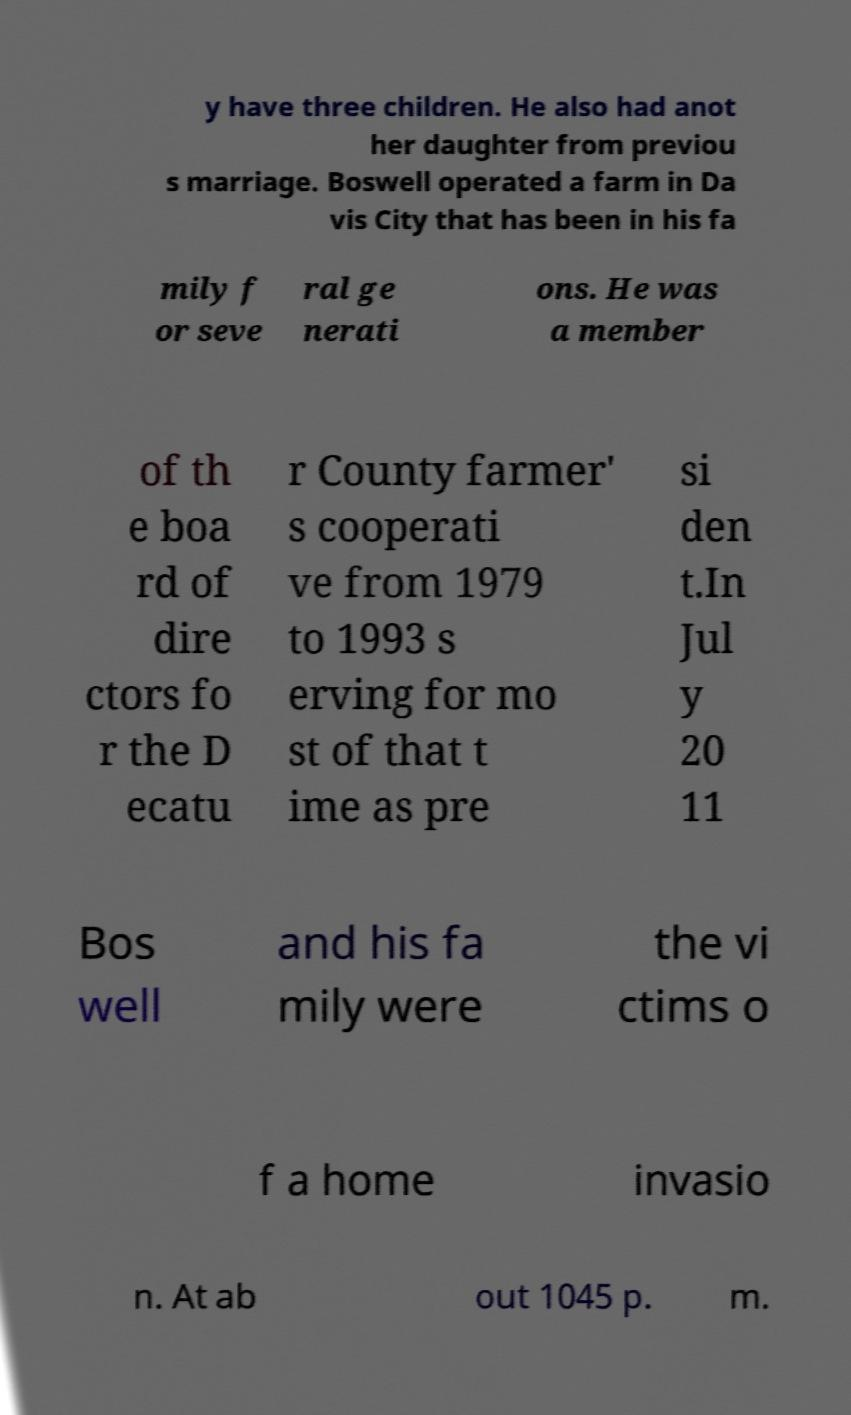Please read and relay the text visible in this image. What does it say? y have three children. He also had anot her daughter from previou s marriage. Boswell operated a farm in Da vis City that has been in his fa mily f or seve ral ge nerati ons. He was a member of th e boa rd of dire ctors fo r the D ecatu r County farmer' s cooperati ve from 1979 to 1993 s erving for mo st of that t ime as pre si den t.In Jul y 20 11 Bos well and his fa mily were the vi ctims o f a home invasio n. At ab out 1045 p. m. 